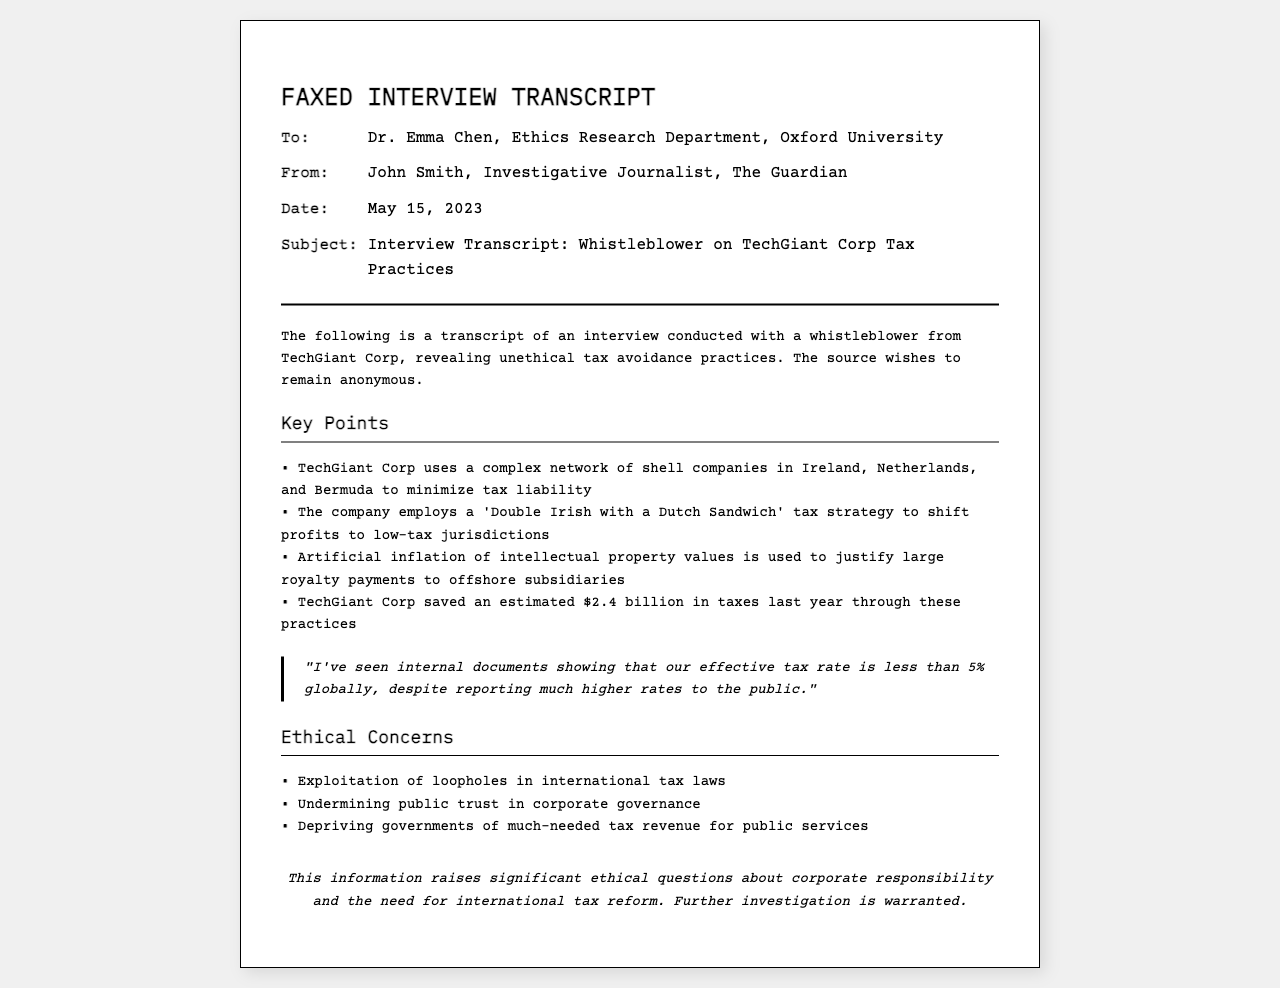what is the subject of the fax? The subject line in the header of the document specifies the topic being discussed in the interview transcript.
Answer: Interview Transcript: Whistleblower on TechGiant Corp Tax Practices who is the whistleblower from? The content of the document indicates the company associated with the whistleblower discussing unethical practices.
Answer: TechGiant Corp how much did TechGiant Corp save in taxes last year? The amount saved through unethical tax practices is mentioned clearly in the document.
Answer: $2.4 billion what tax strategy does TechGiant Corp use? The document highlights the specific tax strategy employed by the company to avoid taxes.
Answer: Double Irish with a Dutch Sandwich what is a significant ethical concern mentioned? The document lists various ethical concerns associated with the practices of TechGiant Corp.
Answer: Exploitation of loopholes what is the effective tax rate for TechGiant Corp globally? The whistleblower provides information regarding the misleading effective tax rate reported by the company.
Answer: less than 5% who conducted the interview? The document specifies who carried out the interview with the whistleblower.
Answer: John Smith which organization did Dr. Emma Chen represent? The header information indicates the affiliation of Dr. Emma Chen mentioned in the document.
Answer: Oxford University 